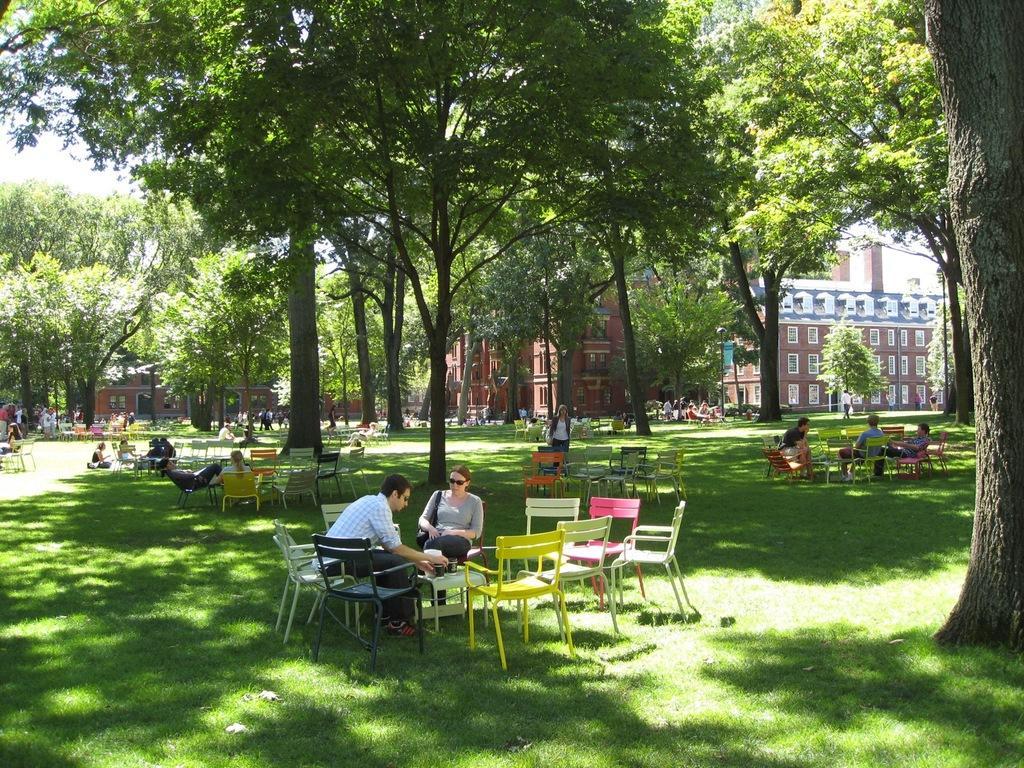Please provide a concise description of this image. In this image there are group of people. There are tables, chairs in the image. There are glasses on the table. At the back there is a building and there are trees. At the top there is a sky. 